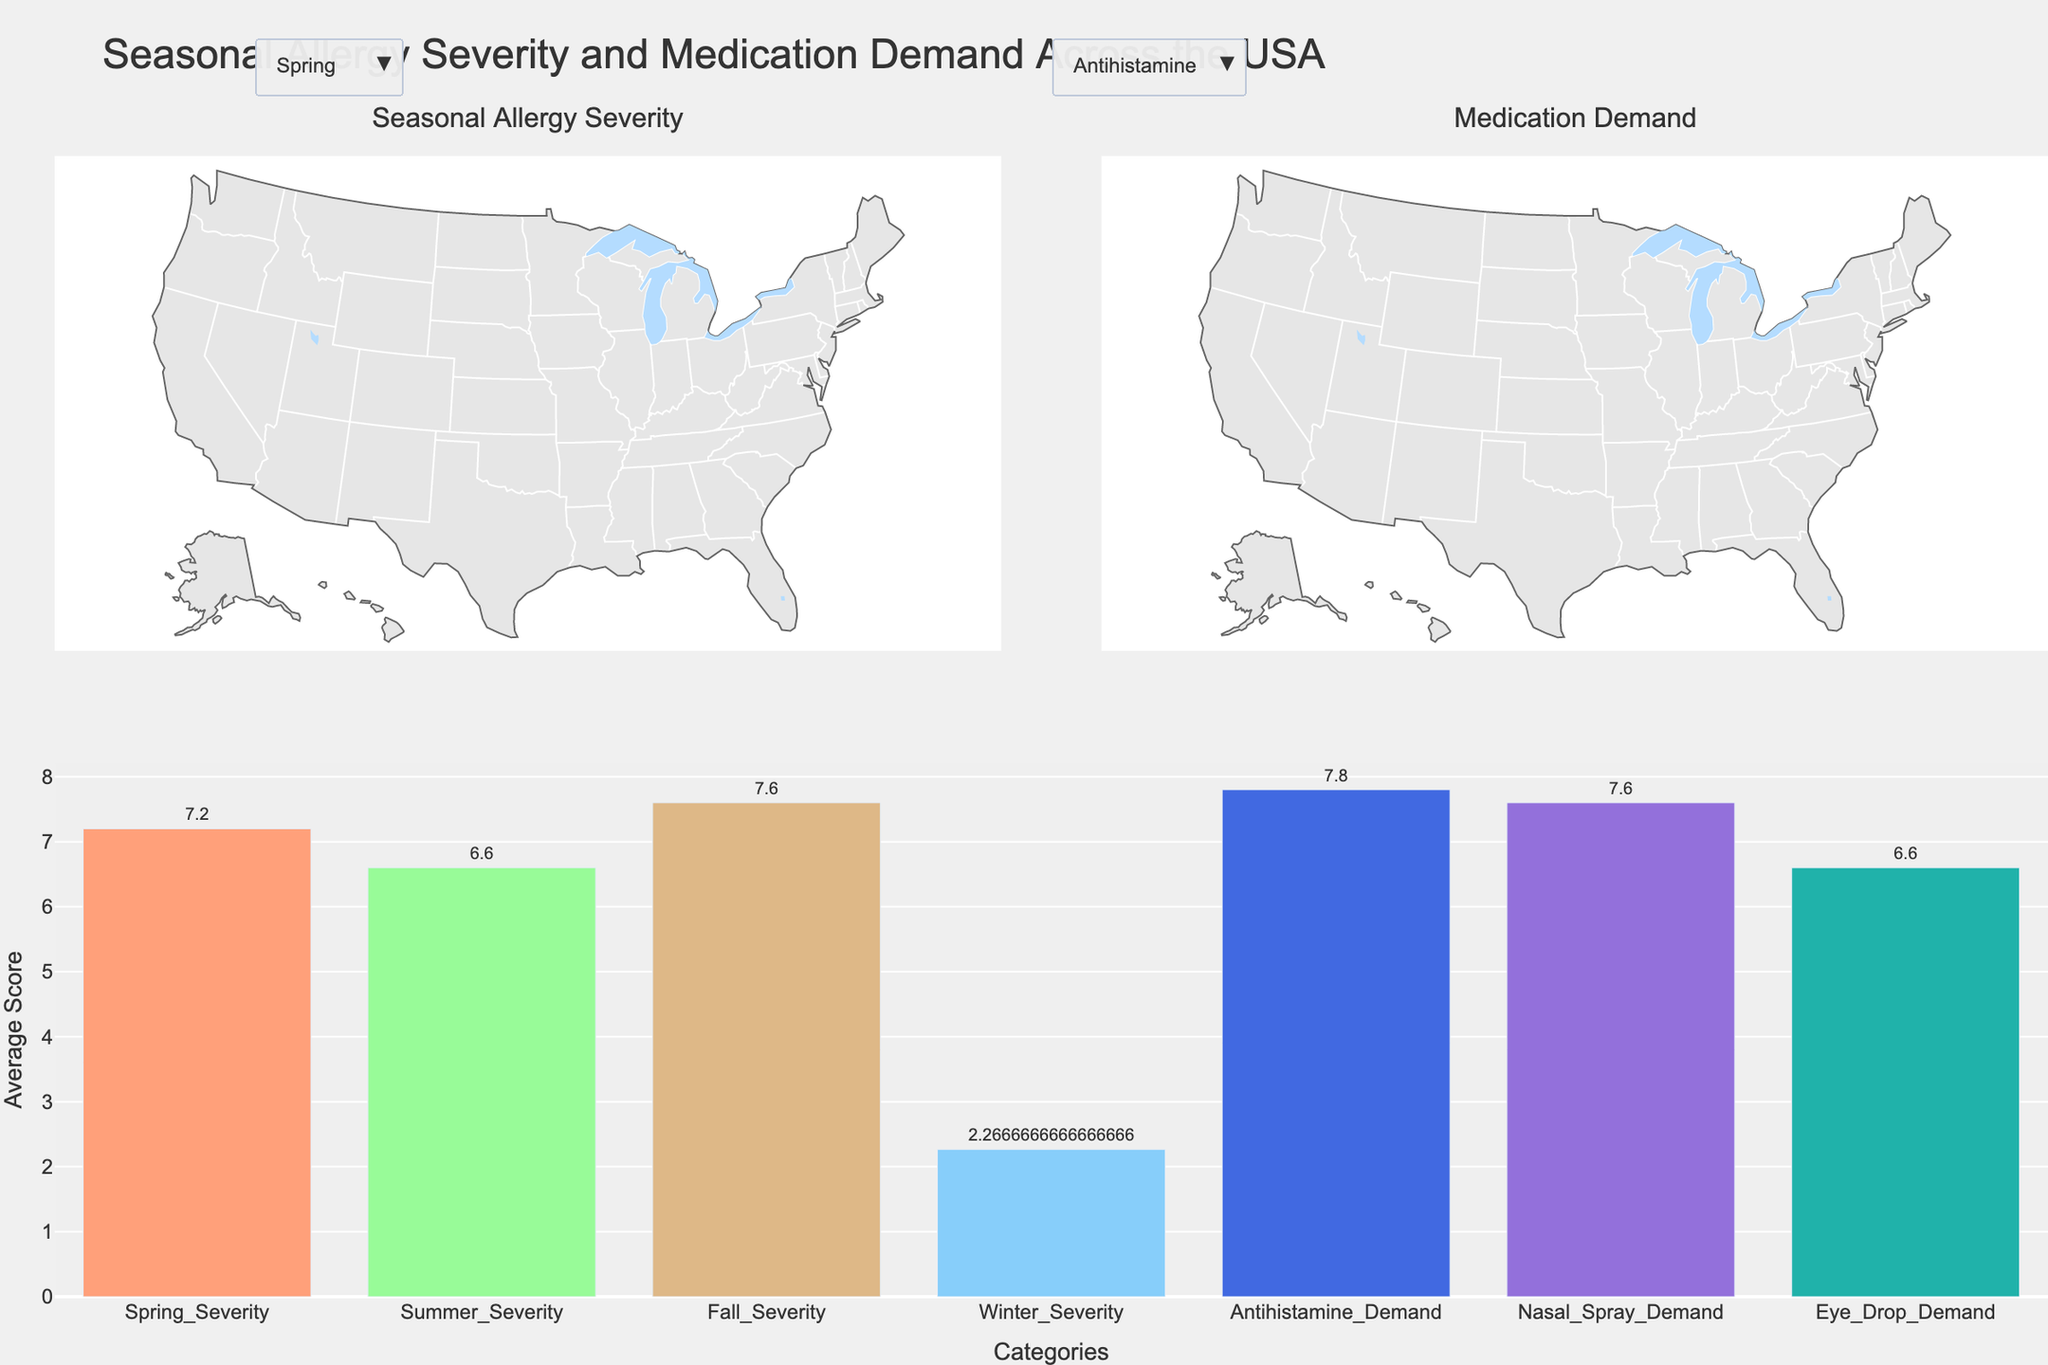Which season has the highest average allergy severity across all states? Check the bar chart for average severity by season. The highest bar corresponds to Fall.
Answer: Fall Which medication type shows the highest average demand? Refer to the bar chart for average medication demand. The highest bar corresponds to Antihistamine.
Answer: Antihistamine How does Georgia's antihistamine demand compare to that of Florida? Refer to the Antihistamine Demand choropleth map. Both Georgia and Florida have equal or almost equal shades, meaning they have the same or similar demand level.
Answer: Similar Which state has the lowest severity in winter? Switch to the Winter seasonal severity choropleth and observe the lightest shade. Illinois shows the lowest severity in winter with a value of 1.
Answer: Illinois What is the average severity for spring and summer? Check the bar chart for average severity. Average Spring Severity = 7.133 and Average Summer Severity = 6.8. Therefore, their average is (7.133 + 6.8) / 2 = 6.967.
Answer: 6.967 Calculate the difference in nasal spray demand between Texas and Washington. Refer to the Nasal Spray Demand choropleth map. Texas has a demand of 8, while Washington has a demand of 7. The difference is 8 - 7 = 1.
Answer: 1 Which state has the highest eye drop demand? Look at the Eye Drop Demand choropleth map and identify the darkest state. Texas has the highest demand with a value of 8.
Answer: Texas Compare the average fall severity with the average antihistamine demand. Are they higher or lower, respectively? Refer to the bar chart. Average Fall Severity is about 7.27 while Antihistamine Demand is about 8. Since 7.27 < 8, Fall Severity is lower than Antihistamine Demand.
Answer: Lower Is there a state with higher severity in summer than in fall? Check the maps of Summer and Fall Severity. New York has a severity of 8 in summer and 7 in fall, indicating higher severity in summer.
Answer: Yes 